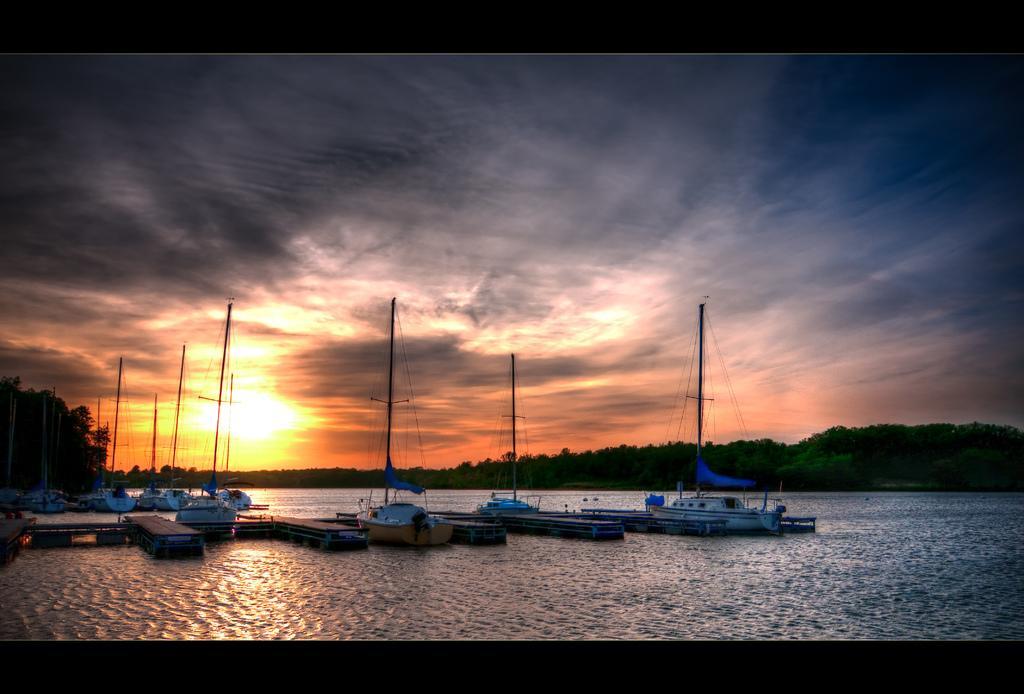Please provide a concise description of this image. In this picture, there is a river. On the river, there are boats which are in blue in color. Towards the bottom left, there is a bridge. In the background, there are trees, sun and a sky. 